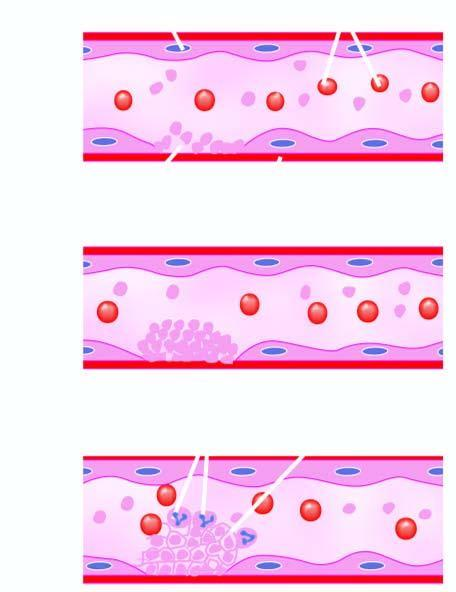s microscopy released which causes further aggregation of platelets following platelet release reaction?
Answer the question using a single word or phrase. No 